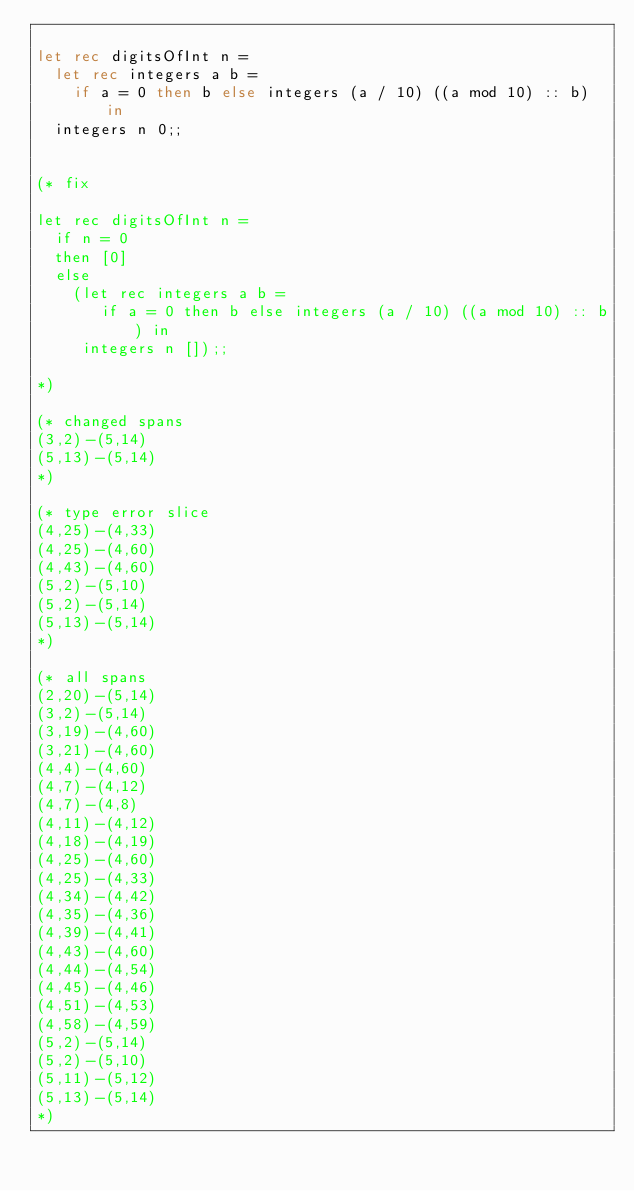<code> <loc_0><loc_0><loc_500><loc_500><_OCaml_>
let rec digitsOfInt n =
  let rec integers a b =
    if a = 0 then b else integers (a / 10) ((a mod 10) :: b) in
  integers n 0;;


(* fix

let rec digitsOfInt n =
  if n = 0
  then [0]
  else
    (let rec integers a b =
       if a = 0 then b else integers (a / 10) ((a mod 10) :: b) in
     integers n []);;

*)

(* changed spans
(3,2)-(5,14)
(5,13)-(5,14)
*)

(* type error slice
(4,25)-(4,33)
(4,25)-(4,60)
(4,43)-(4,60)
(5,2)-(5,10)
(5,2)-(5,14)
(5,13)-(5,14)
*)

(* all spans
(2,20)-(5,14)
(3,2)-(5,14)
(3,19)-(4,60)
(3,21)-(4,60)
(4,4)-(4,60)
(4,7)-(4,12)
(4,7)-(4,8)
(4,11)-(4,12)
(4,18)-(4,19)
(4,25)-(4,60)
(4,25)-(4,33)
(4,34)-(4,42)
(4,35)-(4,36)
(4,39)-(4,41)
(4,43)-(4,60)
(4,44)-(4,54)
(4,45)-(4,46)
(4,51)-(4,53)
(4,58)-(4,59)
(5,2)-(5,14)
(5,2)-(5,10)
(5,11)-(5,12)
(5,13)-(5,14)
*)
</code> 